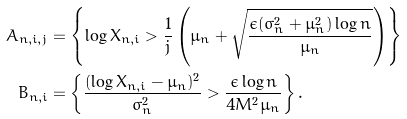Convert formula to latex. <formula><loc_0><loc_0><loc_500><loc_500>A _ { n , i , j } & = \left \{ \log X _ { n , i } > \frac { 1 } { j } \left ( \mu _ { n } + \sqrt { \frac { \epsilon ( \sigma _ { n } ^ { 2 } + \mu _ { n } ^ { 2 } ) \log n } { \mu _ { n } } } \right ) \right \} \\ B _ { n , i } & = \left \{ \frac { ( \log X _ { n , i } - \mu _ { n } ) ^ { 2 } } { \sigma _ { n } ^ { 2 } } > \frac { \epsilon \log n } { 4 M ^ { 2 } \mu _ { n } } \right \} .</formula> 